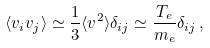<formula> <loc_0><loc_0><loc_500><loc_500>\langle v _ { i } v _ { j } \rangle \simeq \frac { 1 } { 3 } \langle v ^ { 2 } \rangle \delta _ { i j } \simeq \frac { T _ { e } } { m _ { e } } \delta _ { i j } \, ,</formula> 